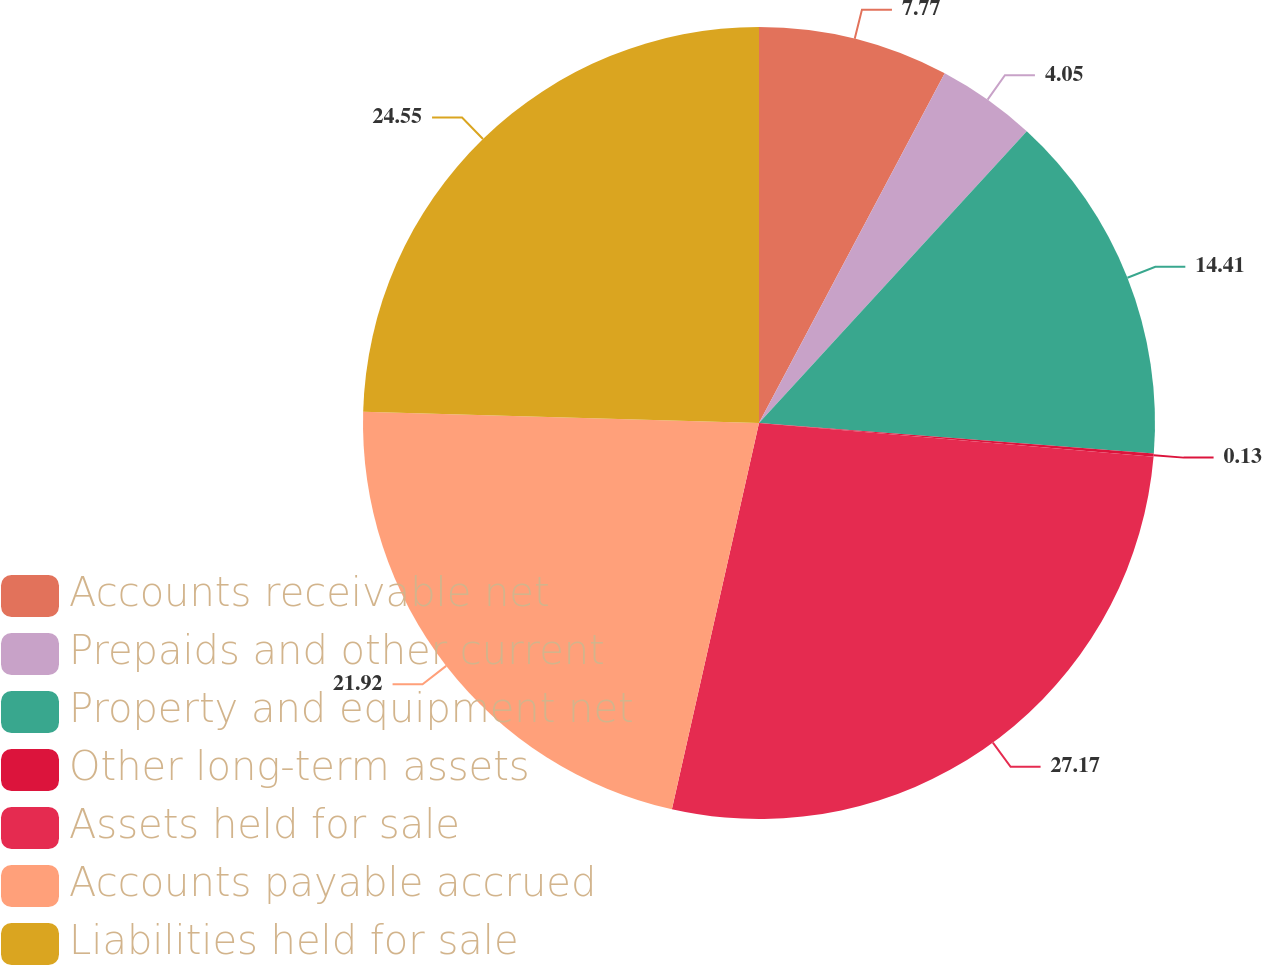Convert chart. <chart><loc_0><loc_0><loc_500><loc_500><pie_chart><fcel>Accounts receivable net<fcel>Prepaids and other current<fcel>Property and equipment net<fcel>Other long-term assets<fcel>Assets held for sale<fcel>Accounts payable accrued<fcel>Liabilities held for sale<nl><fcel>7.77%<fcel>4.05%<fcel>14.41%<fcel>0.13%<fcel>27.17%<fcel>21.92%<fcel>24.55%<nl></chart> 